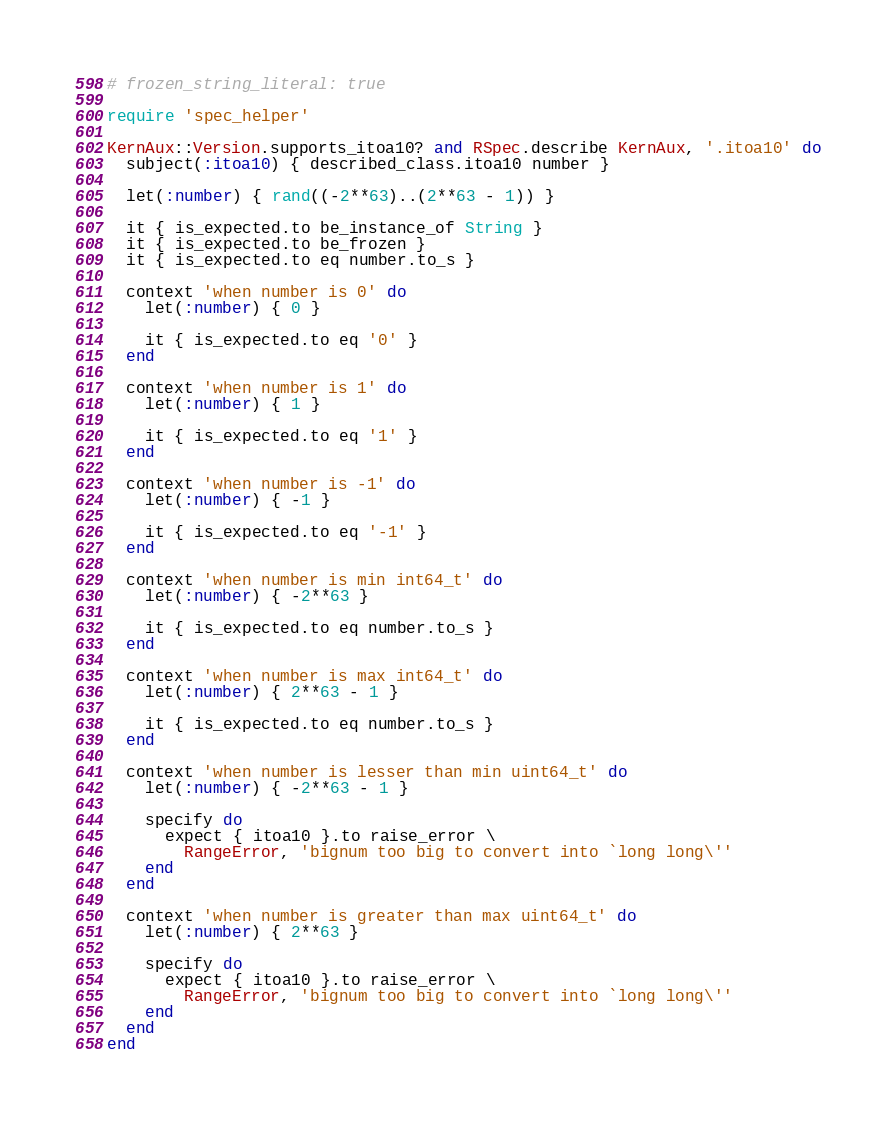Convert code to text. <code><loc_0><loc_0><loc_500><loc_500><_Ruby_># frozen_string_literal: true

require 'spec_helper'

KernAux::Version.supports_itoa10? and RSpec.describe KernAux, '.itoa10' do
  subject(:itoa10) { described_class.itoa10 number }

  let(:number) { rand((-2**63)..(2**63 - 1)) }

  it { is_expected.to be_instance_of String }
  it { is_expected.to be_frozen }
  it { is_expected.to eq number.to_s }

  context 'when number is 0' do
    let(:number) { 0 }

    it { is_expected.to eq '0' }
  end

  context 'when number is 1' do
    let(:number) { 1 }

    it { is_expected.to eq '1' }
  end

  context 'when number is -1' do
    let(:number) { -1 }

    it { is_expected.to eq '-1' }
  end

  context 'when number is min int64_t' do
    let(:number) { -2**63 }

    it { is_expected.to eq number.to_s }
  end

  context 'when number is max int64_t' do
    let(:number) { 2**63 - 1 }

    it { is_expected.to eq number.to_s }
  end

  context 'when number is lesser than min uint64_t' do
    let(:number) { -2**63 - 1 }

    specify do
      expect { itoa10 }.to raise_error \
        RangeError, 'bignum too big to convert into `long long\''
    end
  end

  context 'when number is greater than max uint64_t' do
    let(:number) { 2**63 }

    specify do
      expect { itoa10 }.to raise_error \
        RangeError, 'bignum too big to convert into `long long\''
    end
  end
end
</code> 